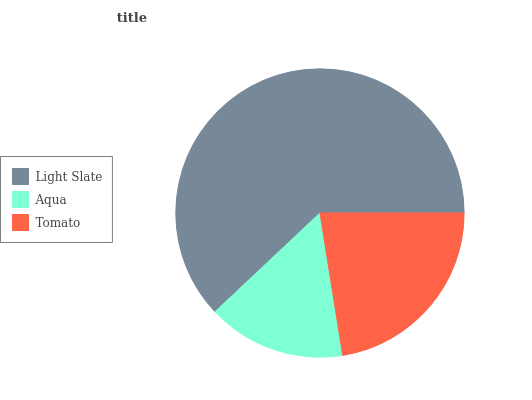Is Aqua the minimum?
Answer yes or no. Yes. Is Light Slate the maximum?
Answer yes or no. Yes. Is Tomato the minimum?
Answer yes or no. No. Is Tomato the maximum?
Answer yes or no. No. Is Tomato greater than Aqua?
Answer yes or no. Yes. Is Aqua less than Tomato?
Answer yes or no. Yes. Is Aqua greater than Tomato?
Answer yes or no. No. Is Tomato less than Aqua?
Answer yes or no. No. Is Tomato the high median?
Answer yes or no. Yes. Is Tomato the low median?
Answer yes or no. Yes. Is Light Slate the high median?
Answer yes or no. No. Is Aqua the low median?
Answer yes or no. No. 